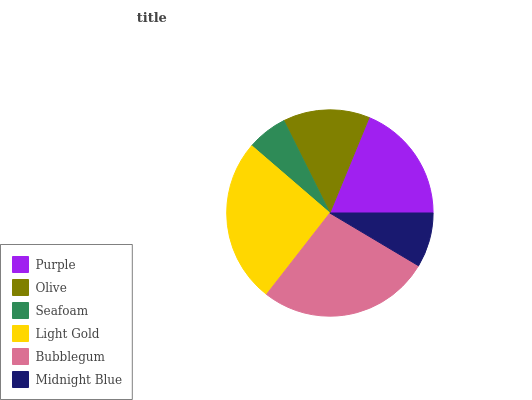Is Seafoam the minimum?
Answer yes or no. Yes. Is Bubblegum the maximum?
Answer yes or no. Yes. Is Olive the minimum?
Answer yes or no. No. Is Olive the maximum?
Answer yes or no. No. Is Purple greater than Olive?
Answer yes or no. Yes. Is Olive less than Purple?
Answer yes or no. Yes. Is Olive greater than Purple?
Answer yes or no. No. Is Purple less than Olive?
Answer yes or no. No. Is Purple the high median?
Answer yes or no. Yes. Is Olive the low median?
Answer yes or no. Yes. Is Seafoam the high median?
Answer yes or no. No. Is Bubblegum the low median?
Answer yes or no. No. 